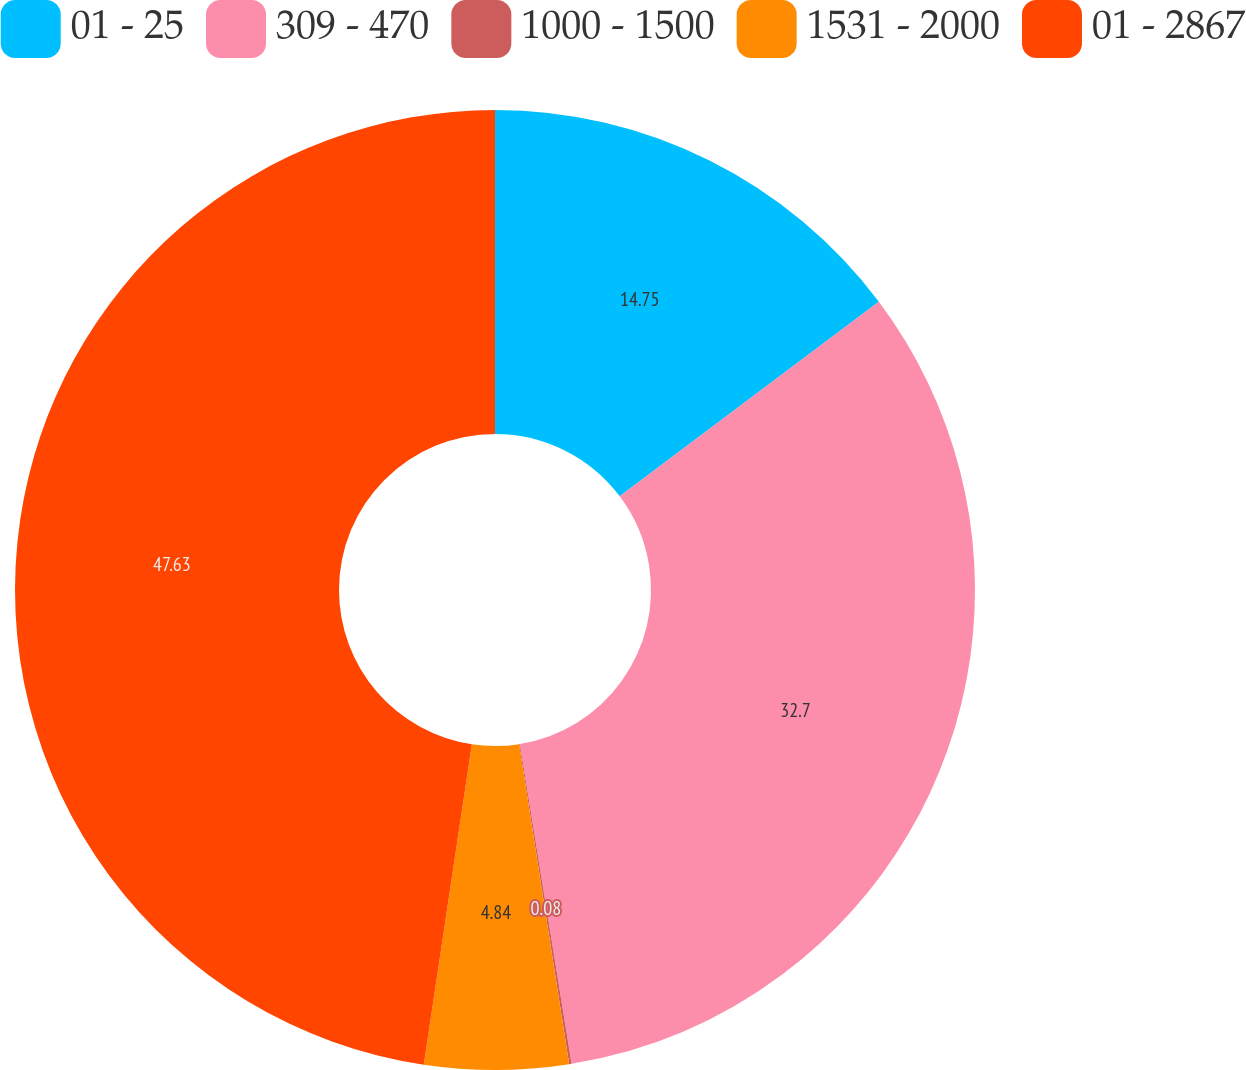Convert chart to OTSL. <chart><loc_0><loc_0><loc_500><loc_500><pie_chart><fcel>01 - 25<fcel>309 - 470<fcel>1000 - 1500<fcel>1531 - 2000<fcel>01 - 2867<nl><fcel>14.75%<fcel>32.7%<fcel>0.08%<fcel>4.84%<fcel>47.63%<nl></chart> 